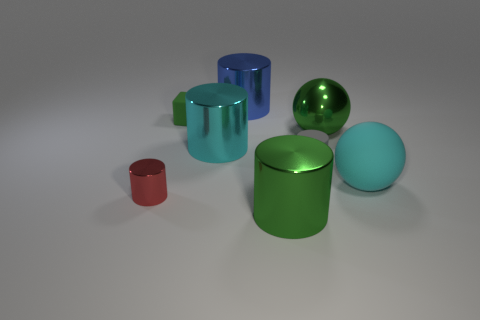Subtract 1 cylinders. How many cylinders are left? 4 Subtract all small metallic cylinders. How many cylinders are left? 4 Subtract all blue cylinders. How many cylinders are left? 4 Subtract all yellow cylinders. Subtract all blue cubes. How many cylinders are left? 5 Add 1 big cyan cylinders. How many objects exist? 9 Subtract all blocks. How many objects are left? 7 Add 8 tiny purple cylinders. How many tiny purple cylinders exist? 8 Subtract 1 green cylinders. How many objects are left? 7 Subtract all yellow objects. Subtract all tiny red things. How many objects are left? 7 Add 5 big blue things. How many big blue things are left? 6 